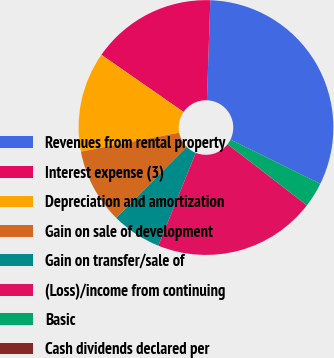<chart> <loc_0><loc_0><loc_500><loc_500><pie_chart><fcel>Revenues from rental property<fcel>Interest expense (3)<fcel>Depreciation and amortization<fcel>Gain on sale of development<fcel>Gain on transfer/sale of<fcel>(Loss)/income from continuing<fcel>Basic<fcel>Cash dividends declared per<nl><fcel>31.74%<fcel>15.87%<fcel>12.7%<fcel>9.52%<fcel>6.35%<fcel>20.65%<fcel>3.17%<fcel>0.0%<nl></chart> 